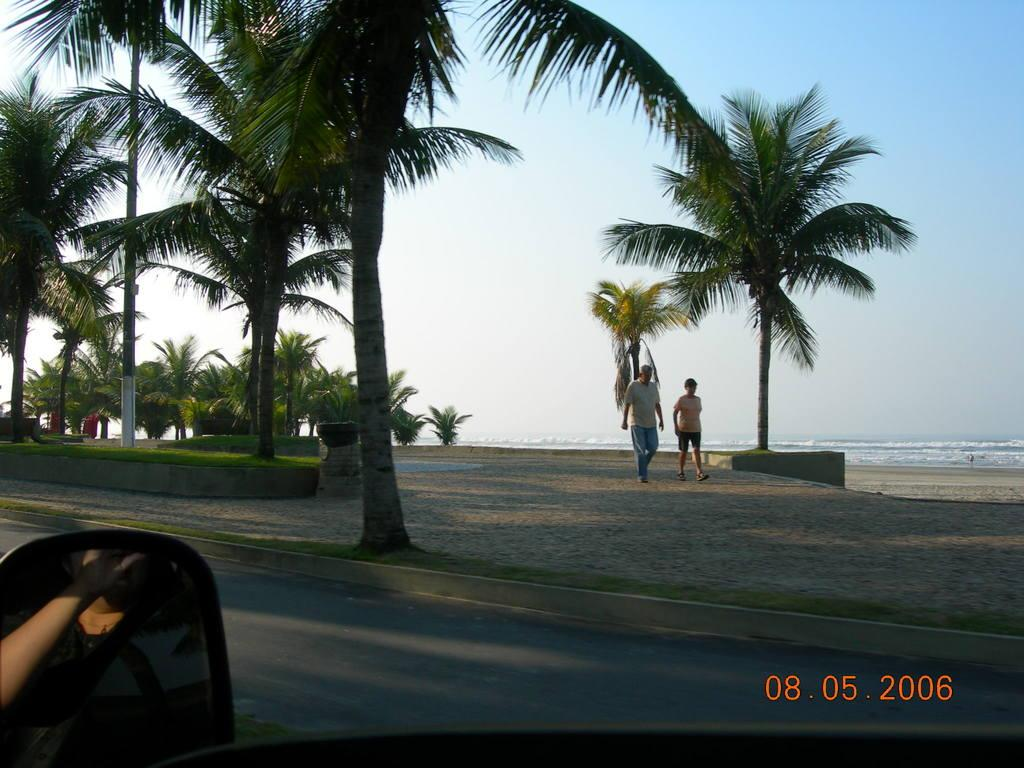What are the two persons in the image doing? The two persons in the image are walking on the sand. What type of vegetation can be seen in the image? There are trees and grass in the image. What structure is present in the image? There is a pole in the image. What natural element is visible in the image? A: There is water in the image. What object is used for reflection in the image? There is a mirror in the image, and a person is visible in the mirror. What is visible in the background of the image? The sky is visible in the background of the image. What type of boot is being used to write on the paper in the image? There is no boot or paper present in the image. What type of loss is depicted in the image? There is no loss depicted in the image; it features two persons walking on the sand, trees, grass, a pole, water, a mirror, and the sky. 